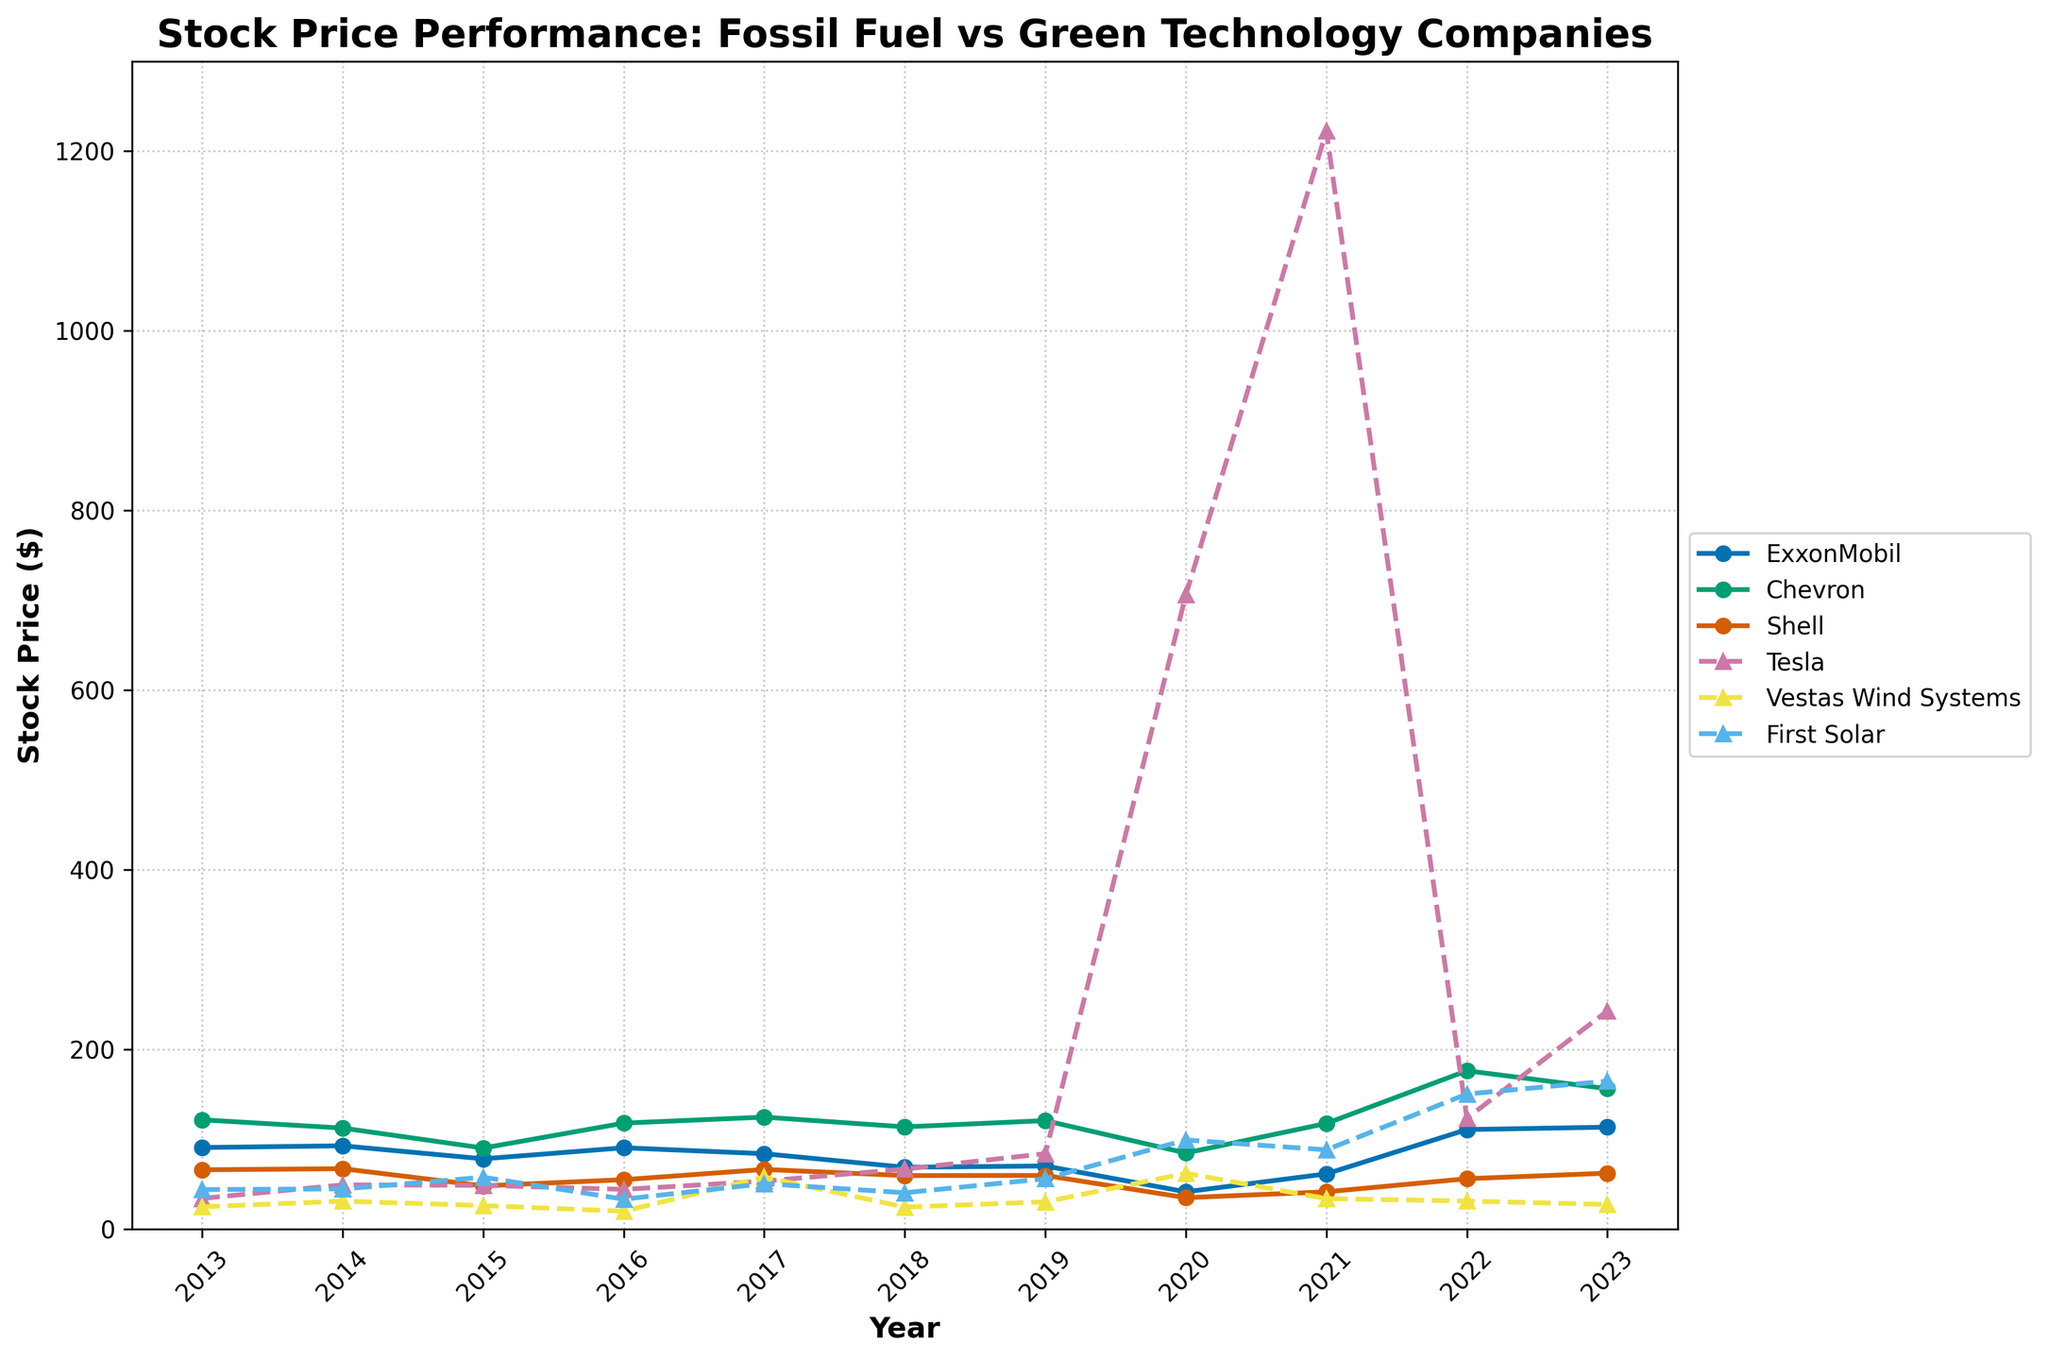Which company had the highest stock price in any year? Tesla had the highest stock price in 2021 with a value of 1222.09. This can be observed by comparing the peak points of all the companies' lines in the graph.
Answer: Tesla How did ExxonMobil's stock price change from 2020 to 2023? ExxonMobil's stock price increased from 41.22 in 2020 to 113.21 in 2023. Subtract the initial value (41.22) from the final value (113.21) to get the difference, which is 71.99.
Answer: 71.99 Which green technology firm showed the highest volatility in stock prices over the decade? Tesla showed the highest volatility in stock prices over the decade, evidenced by its dramatic rise and fall in stock prices, culminating in a peak of 1222.09 in 2021 and drops to values like 242.54 in 2023.
Answer: Tesla On average, how did the stock prices of First Solar change from 2013 to 2023? To calculate the average change in First Solar's stock prices, take the stock values for each year from 2013 to 2023: (43.72, 44.42, 57.43, 33.03, 50.29, 40.18, 55.78, 98.92, 87.93, 150.07, 164.50). Calculate the average: (43.72+44.42+57.43+33.03+50.29+40.18+55.78+98.92+87.93+150.07+164.50)/11, which equals 72.75.
Answer: 72.75 Compare the stock performance of Chevron and Shell in 2015. Which company had a better performance? In 2015, Chevron had a stock price of 89.96, whereas Shell had a stock price of 47.84. Thus, Chevron performed significantly better than Shell in that year.
Answer: Chevron What was the stock price trend for Vestas Wind Systems from 2013 to 2023? To analyze the stock price trend for Vestas Wind Systems, observe the line plot markers: 24.51 (2013), 30.89 (2014), 25.88 (2015), 19.60 (2016), 57.62 (2017), 24.15 (2018), 30.04 (2019), 61.80 (2020), 33.60 (2021), 30.96 (2022), and 27.15 (2023). There was considerable fluctuation, with notable peaks in 2017 and 2020, but a general increase compared to the start.
Answer: Fluctuating Between 2018 and 2021, which fossil fuel company showed the strongest recovery in stock prices after any decrease? Chevron showed the strongest recovery. Its stock price decreased from 113.51 in 2018 to 84.45 in 2020, then increased to 117.35 in 2021. This indicates a substantial recovery considering the drop and subsequent rise.
Answer: Chevron Which company maintained a relatively stable stock price around $50 throughout the decade? Shell maintained a relatively stable stock price around $50, with prices fluctuating closely around this value: 65.76 (2013), 66.95 (2014), 47.84 (2015), 54.73 (2016), 66.13 (2017), 59.30 (2018), 59.44 (2019), 34.68 (2020), 41.20 (2021), 55.81 (2022), and 61.98 (2023).
Answer: Shell What was the overall performance difference between ExxonMobil and Tesla from 2013 to 2023? Compare the starting and ending values for ExxonMobil (90.54 in 2013, 113.21 in 2023) and Tesla (33.87 in 2013, 242.54 in 2023). The difference for ExxonMobil is 113.21 - 90.54 = 22.67, and for Tesla, 242.54 - 33.87 = 208.67. It's evident Tesla had a more substantial overall performance increase.
Answer: Tesla How did the stock prices of all companies compare in 2020? In 2020, the stock prices were: ExxonMobil (41.22), Chevron (84.45), Shell (34.68), Tesla (705.67), Vestas Wind Systems (61.80), and First Solar (98.92). Tesla had the highest stock price, followed by First Solar and Chevron. Shell had the lowest stock price among these companies.
Answer: Tesla, First Solar, Chevron 